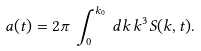<formula> <loc_0><loc_0><loc_500><loc_500>a ( t ) = 2 \pi \, \int _ { 0 } ^ { k _ { 0 } } \, d k \, k ^ { 3 } S ( k , t ) .</formula> 